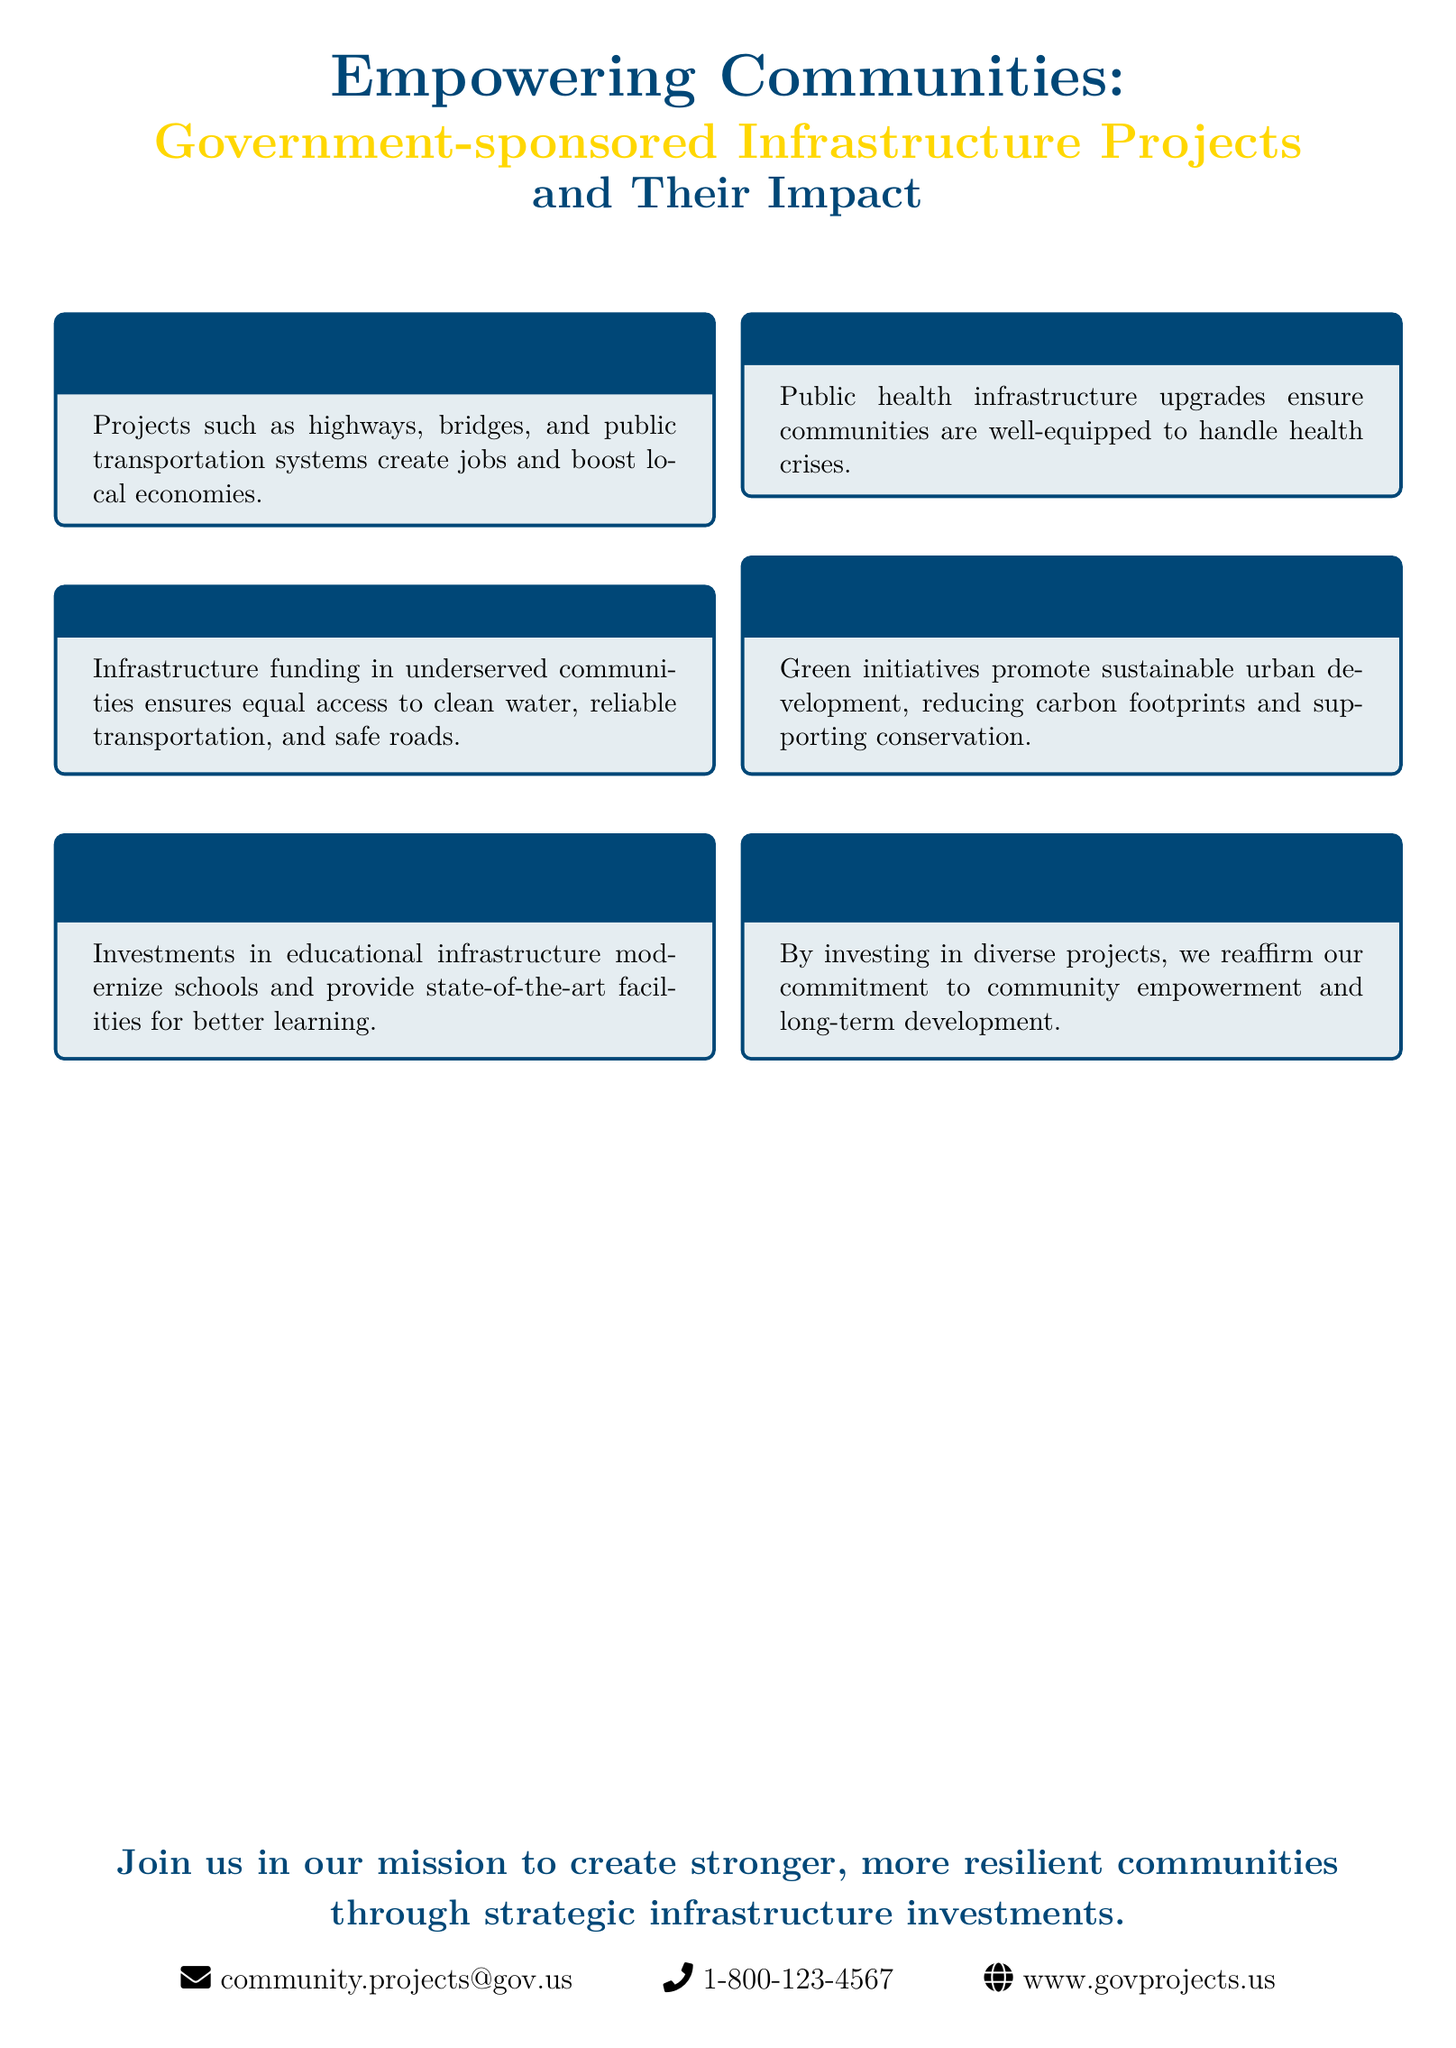What is the main focus of the flyer? The main focus of the flyer is government-sponsored infrastructure projects and their impact on communities.
Answer: government-sponsored infrastructure projects and their impact How many key areas are highlighted in the flyer? The flyer highlights six key areas of impact related to infrastructure projects.
Answer: six What is the email contact provided in the flyer? The flyer provides the email contact for community projects as mentioned in the contact information section.
Answer: community.projects@gov.us Which area focuses on ensuring equal access to essential services? The area related to social equity and accessibility addresses equal access to essential services in underserved communities.
Answer: Social Equity & Accessibility What aspect does the conclusion emphasize? The conclusion emphasizes the government's commitment to community empowerment and long-term development through various projects.
Answer: Our Commitment to Progress What type of infrastructure projects are mentioned under economic growth? Under economic growth, projects such as highways, bridges, and public transportation systems are mentioned.
Answer: highways, bridges, and public transportation systems How does the flyer suggest to engage with its initiative? The flyer suggests joining in the mission to create stronger, more resilient communities through strategic infrastructure investments.
Answer: Join us in our mission What is the primary color used for headings in the flyer? The primary color used for headings in the flyer is dark blue, specified as maincolor.
Answer: dark blue 